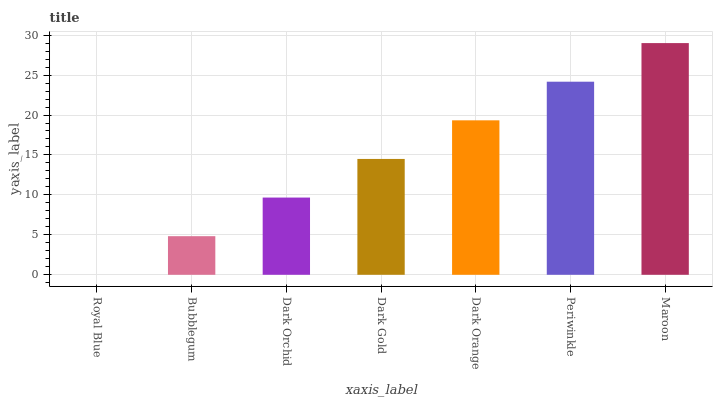Is Royal Blue the minimum?
Answer yes or no. Yes. Is Maroon the maximum?
Answer yes or no. Yes. Is Bubblegum the minimum?
Answer yes or no. No. Is Bubblegum the maximum?
Answer yes or no. No. Is Bubblegum greater than Royal Blue?
Answer yes or no. Yes. Is Royal Blue less than Bubblegum?
Answer yes or no. Yes. Is Royal Blue greater than Bubblegum?
Answer yes or no. No. Is Bubblegum less than Royal Blue?
Answer yes or no. No. Is Dark Gold the high median?
Answer yes or no. Yes. Is Dark Gold the low median?
Answer yes or no. Yes. Is Bubblegum the high median?
Answer yes or no. No. Is Maroon the low median?
Answer yes or no. No. 